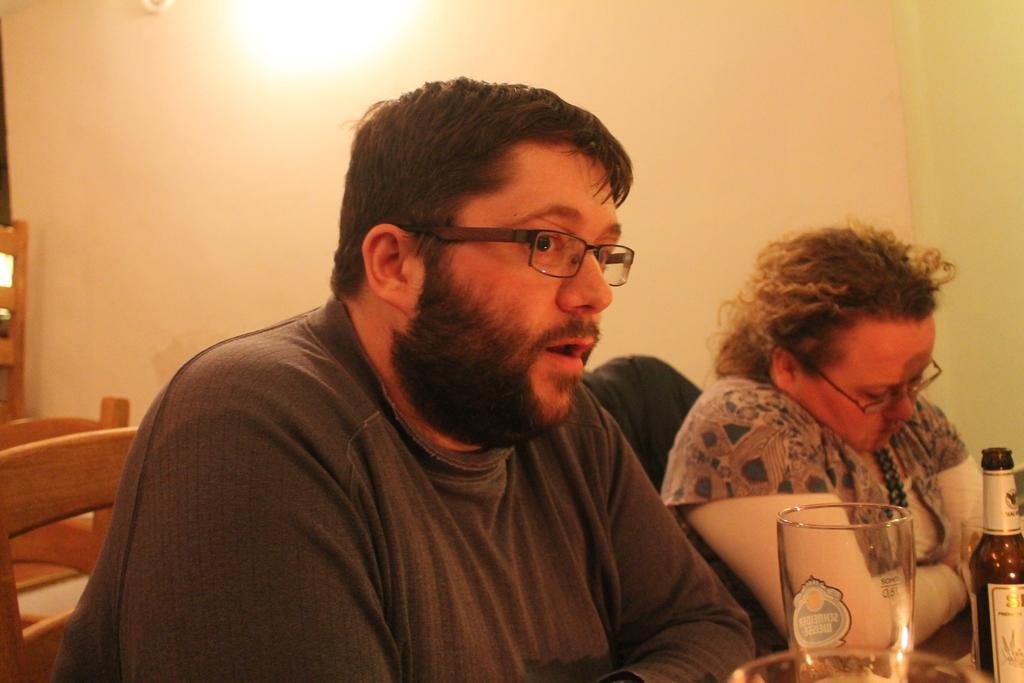Describe this image in one or two sentences. There are 2 people sitting here on the chair. On the table there is a glass and wine bottle. This is a wall. 